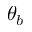Convert formula to latex. <formula><loc_0><loc_0><loc_500><loc_500>\theta _ { b }</formula> 